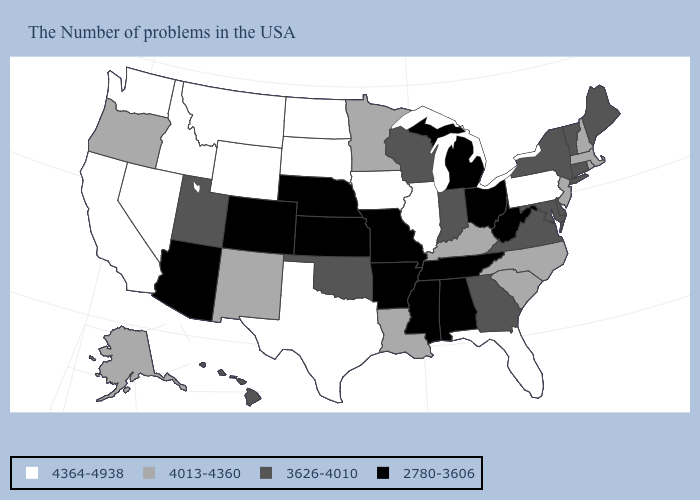Is the legend a continuous bar?
Write a very short answer. No. What is the value of New Mexico?
Short answer required. 4013-4360. Which states have the lowest value in the MidWest?
Concise answer only. Ohio, Michigan, Missouri, Kansas, Nebraska. Among the states that border Vermont , which have the highest value?
Keep it brief. Massachusetts, New Hampshire. What is the lowest value in states that border Oregon?
Give a very brief answer. 4364-4938. Does Idaho have the highest value in the West?
Quick response, please. Yes. Name the states that have a value in the range 4013-4360?
Give a very brief answer. Massachusetts, Rhode Island, New Hampshire, New Jersey, North Carolina, South Carolina, Kentucky, Louisiana, Minnesota, New Mexico, Oregon, Alaska. What is the value of Maine?
Give a very brief answer. 3626-4010. Among the states that border Kansas , does Oklahoma have the highest value?
Be succinct. Yes. What is the value of Mississippi?
Be succinct. 2780-3606. Name the states that have a value in the range 3626-4010?
Give a very brief answer. Maine, Vermont, Connecticut, New York, Delaware, Maryland, Virginia, Georgia, Indiana, Wisconsin, Oklahoma, Utah, Hawaii. Which states have the lowest value in the USA?
Give a very brief answer. West Virginia, Ohio, Michigan, Alabama, Tennessee, Mississippi, Missouri, Arkansas, Kansas, Nebraska, Colorado, Arizona. Does the first symbol in the legend represent the smallest category?
Write a very short answer. No. What is the value of Minnesota?
Short answer required. 4013-4360. What is the value of Massachusetts?
Concise answer only. 4013-4360. 